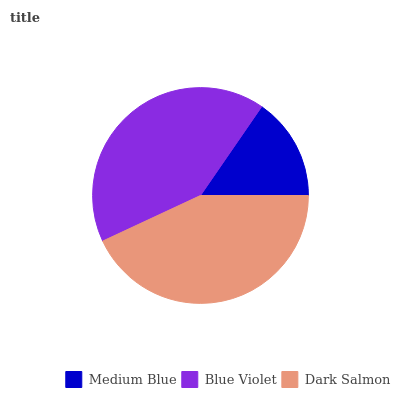Is Medium Blue the minimum?
Answer yes or no. Yes. Is Dark Salmon the maximum?
Answer yes or no. Yes. Is Blue Violet the minimum?
Answer yes or no. No. Is Blue Violet the maximum?
Answer yes or no. No. Is Blue Violet greater than Medium Blue?
Answer yes or no. Yes. Is Medium Blue less than Blue Violet?
Answer yes or no. Yes. Is Medium Blue greater than Blue Violet?
Answer yes or no. No. Is Blue Violet less than Medium Blue?
Answer yes or no. No. Is Blue Violet the high median?
Answer yes or no. Yes. Is Blue Violet the low median?
Answer yes or no. Yes. Is Medium Blue the high median?
Answer yes or no. No. Is Medium Blue the low median?
Answer yes or no. No. 